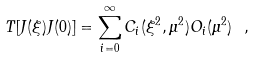Convert formula to latex. <formula><loc_0><loc_0><loc_500><loc_500>T [ J ( \xi ) J ( 0 ) ] = \sum _ { i = 0 } ^ { \infty } C _ { i } ( \xi ^ { 2 } , \mu ^ { 2 } ) O _ { i } ( \mu ^ { 2 } ) \ ,</formula> 